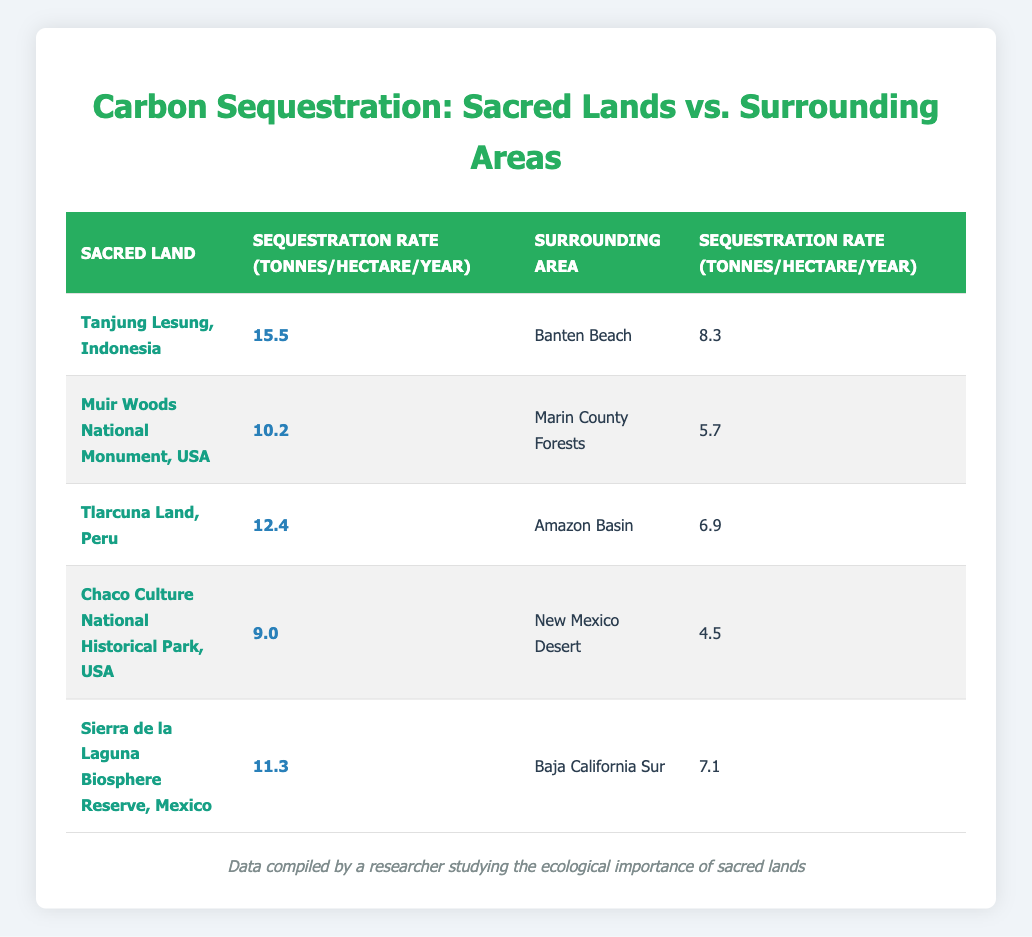What is the highest carbon sequestration rate among sacred lands? The highest carbon sequestration rate listed in the table is 15.5 tonnes per hectare per year, which is found in Tanjung Lesung, Indonesia.
Answer: 15.5 What is the surrounding area of Tlarcuna Land, Peru? The surrounding area of Tlarcuna Land, Peru, is the Amazon Basin, as indicated in the table.
Answer: Amazon Basin What is the difference in carbon sequestration rates between sacred lands and their surrounding areas for Muir Woods National Monument, USA? For Muir Woods National Monument, the sacred land has a sequestration rate of 10.2 tonnes per hectare per year, while the surrounding area (Marin County Forests) has 5.7 tonnes per hectare per year. The difference is 10.2 - 5.7 = 4.5 tonnes per hectare per year.
Answer: 4.5 Does the Chaco Culture National Historical Park have a higher sequestration rate than the New Mexico Desert? Yes, the Chaco Culture National Historical Park (9.0 tonnes per hectare per year) has a higher sequestration rate than the New Mexico Desert (4.5 tonnes per hectare per year).
Answer: Yes What is the average carbon sequestration rate for the sacred lands listed in the table? The average carbon sequestration rate can be calculated by summing the rates for all sacred lands (15.5 + 10.2 + 12.4 + 9.0 + 11.3) which equals 58.4 tonnes per hectare per year. Dividing by the number of sacred lands (5) gives 58.4 / 5 = 11.68 tonnes per hectare per year.
Answer: 11.68 What is the lowest carbon sequestration rate for a surrounding area listed in the table? The lowest carbon sequestration rate for a surrounding area is 4.5 tonnes per hectare per year, which corresponds to the New Mexico Desert.
Answer: 4.5 Is the carbon sequestration rate for Sierra de la Laguna Biosphere Reserve higher than that for Tlarcuna Land? Yes, Sierra de la Laguna Biosphere Reserve has a rate of 11.3 tonnes per hectare per year, which is higher than Tlarcuna Land's rate of 12.4 tonnes per hectare per year.
Answer: No What is the total carbon sequestration rate for both Tanjung Lesung and Muir Woods National Monument? The total carbon sequestration rate for Tanjung Lesung (15.5 tonnes) and Muir Woods (10.2 tonnes) is calculated by adding the two: 15.5 + 10.2 = 25.7 tonnes per hectare per year.
Answer: 25.7 How many sacred lands have a sequestration rate higher than 10 tonnes per hectare per year? Analyzing the table, Tanjung Lesung (15.5), Muir Woods (10.2), Tlarcuna Land (12.4), and Sierra de la Laguna (11.3) all exceed 10 tonnes per hectare per year. Thus, there are 4 sacred lands that meet this criterion.
Answer: 4 